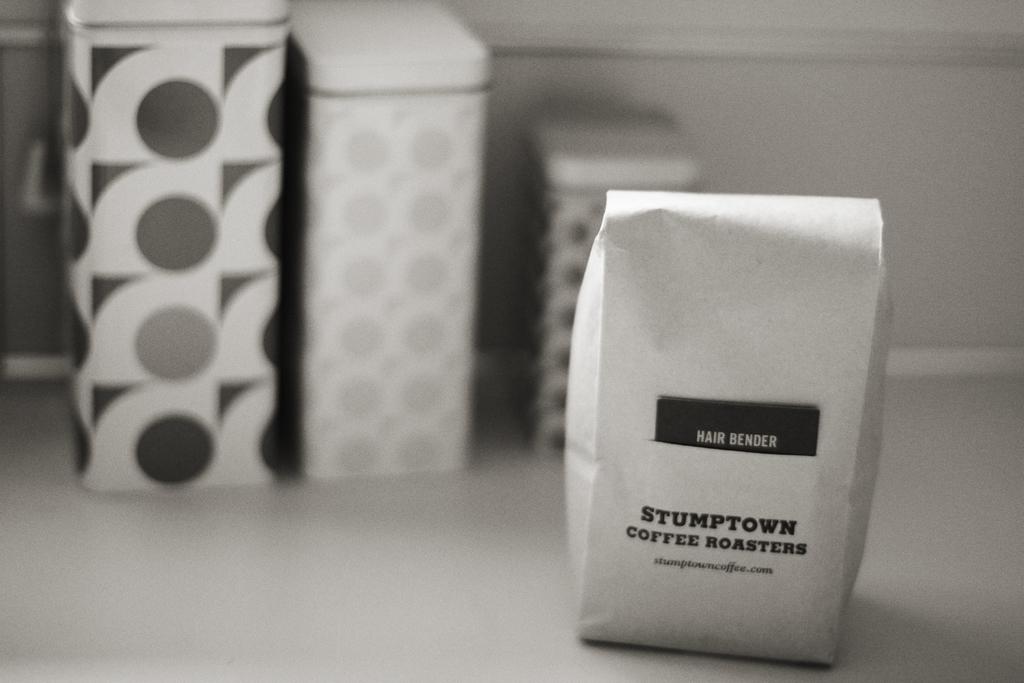What is inside the package?
Make the answer very short. Coffee roasters. 